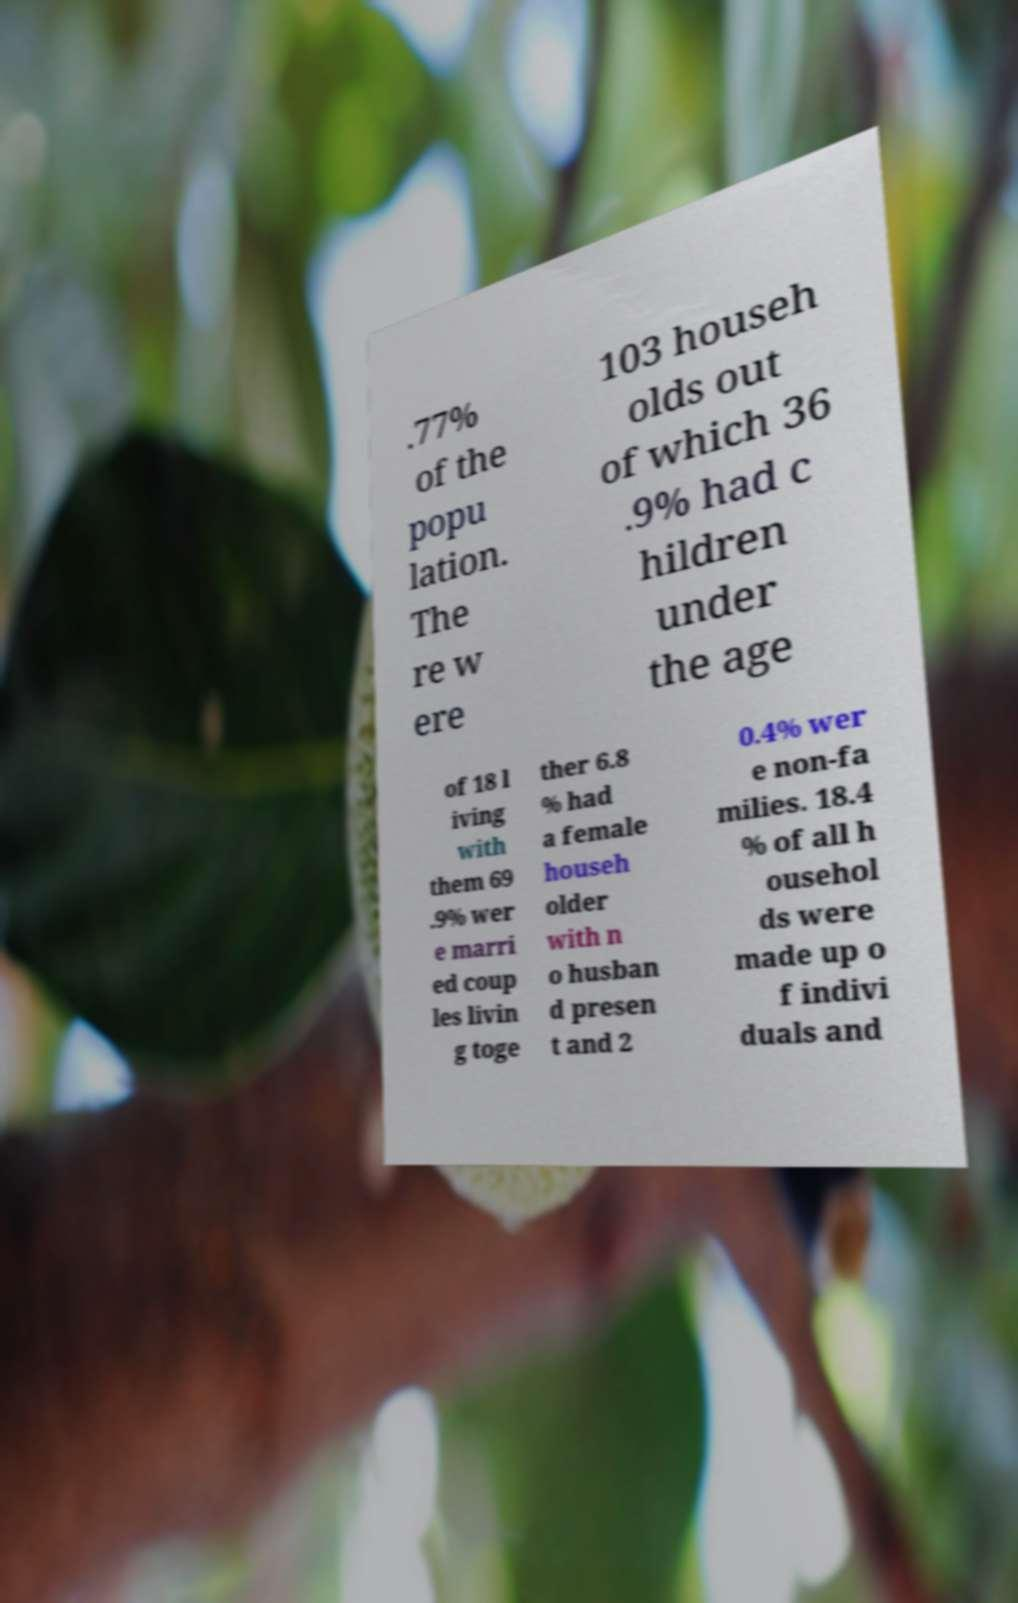Please read and relay the text visible in this image. What does it say? .77% of the popu lation. The re w ere 103 househ olds out of which 36 .9% had c hildren under the age of 18 l iving with them 69 .9% wer e marri ed coup les livin g toge ther 6.8 % had a female househ older with n o husban d presen t and 2 0.4% wer e non-fa milies. 18.4 % of all h ousehol ds were made up o f indivi duals and 